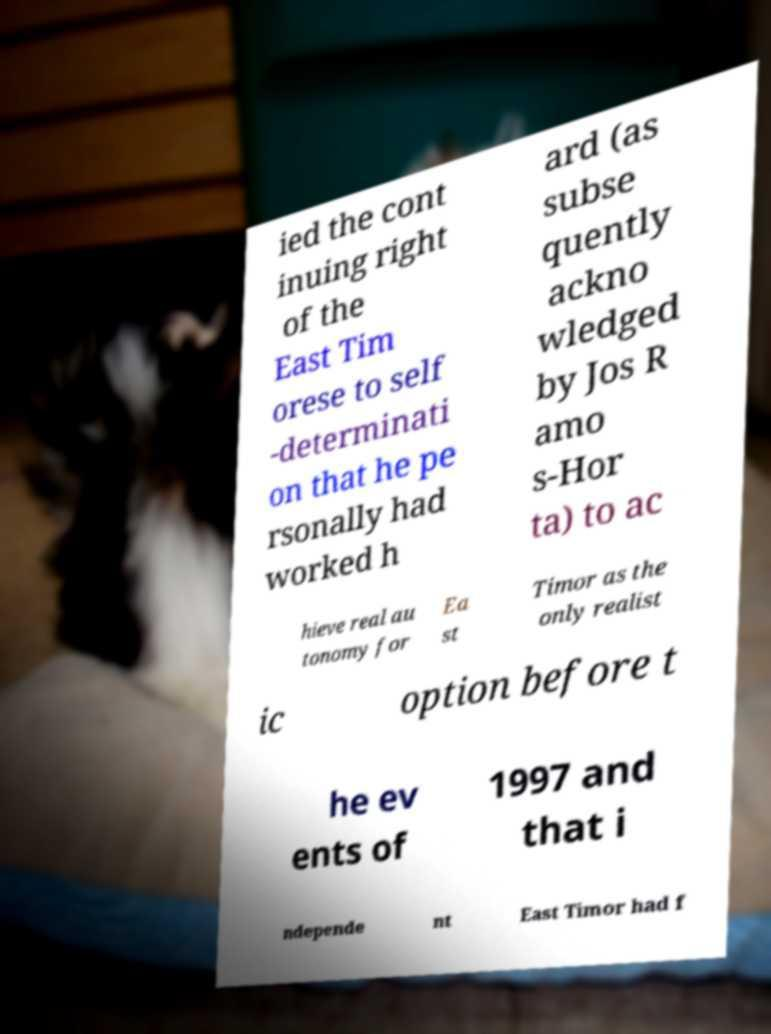Please read and relay the text visible in this image. What does it say? ied the cont inuing right of the East Tim orese to self -determinati on that he pe rsonally had worked h ard (as subse quently ackno wledged by Jos R amo s-Hor ta) to ac hieve real au tonomy for Ea st Timor as the only realist ic option before t he ev ents of 1997 and that i ndepende nt East Timor had f 